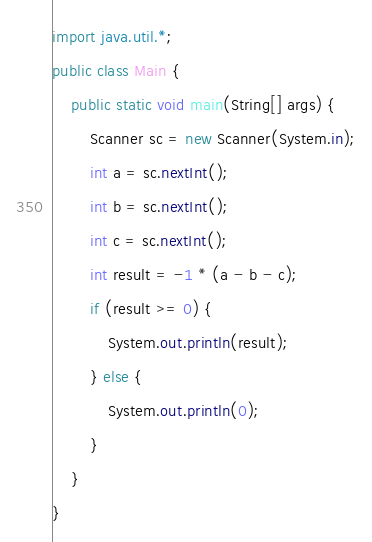<code> <loc_0><loc_0><loc_500><loc_500><_Java_>import java.util.*;
public class Main {
    public static void main(String[] args) {
        Scanner sc = new Scanner(System.in);
        int a = sc.nextInt();
        int b = sc.nextInt();
        int c = sc.nextInt();
        int result = -1 * (a - b - c);
        if (result >= 0) {
            System.out.println(result);
        } else {
            System.out.println(0);
        }
    }
}
</code> 